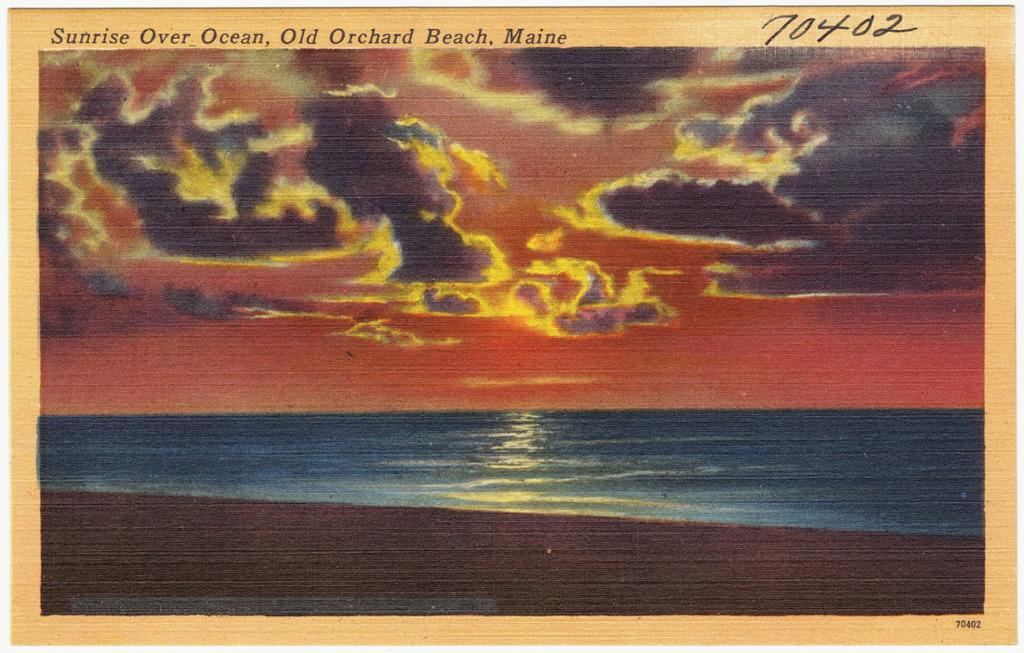<image>
Summarize the visual content of the image. an old post card for Old Orchard Beach, Maine has a sunset on it 